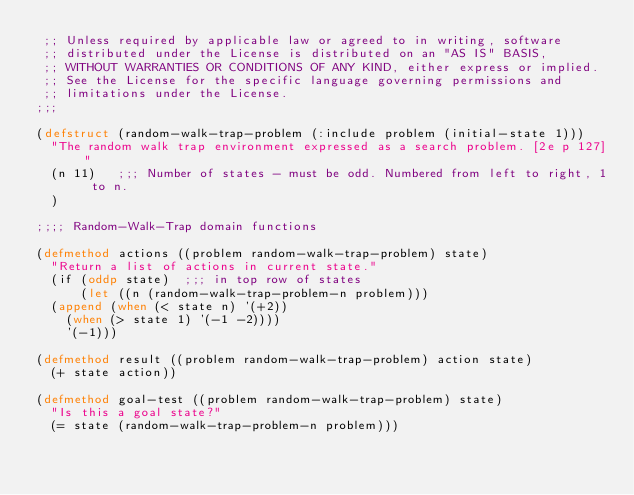Convert code to text. <code><loc_0><loc_0><loc_500><loc_500><_Lisp_> ;; Unless required by applicable law or agreed to in writing, software
 ;; distributed under the License is distributed on an "AS IS" BASIS,
 ;; WITHOUT WARRANTIES OR CONDITIONS OF ANY KIND, either express or implied.
 ;; See the License for the specific language governing permissions and
 ;; limitations under the License.
;;;

(defstruct (random-walk-trap-problem (:include problem (initial-state 1)))
  "The random walk trap environment expressed as a search problem. [2e p 127]"
  (n 11)   ;;; Number of states - must be odd. Numbered from left to right, 1 to n.
  )

;;;; Random-Walk-Trap domain functions

(defmethod actions ((problem random-walk-trap-problem) state)
  "Return a list of actions in current state."
  (if (oddp state)  ;;; in top row of states
      (let ((n (random-walk-trap-problem-n problem)))
	(append (when (< state n) '(+2))
		(when (> state 1) '(-1 -2))))
    '(-1)))

(defmethod result ((problem random-walk-trap-problem) action state)
  (+ state action))

(defmethod goal-test ((problem random-walk-trap-problem) state)
  "Is this a goal state?"
  (= state (random-walk-trap-problem-n problem)))

</code> 